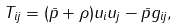<formula> <loc_0><loc_0><loc_500><loc_500>T _ { i j } = ( \bar { p } + \rho ) u _ { i } u _ { j } - \bar { p } g _ { i j } ,</formula> 